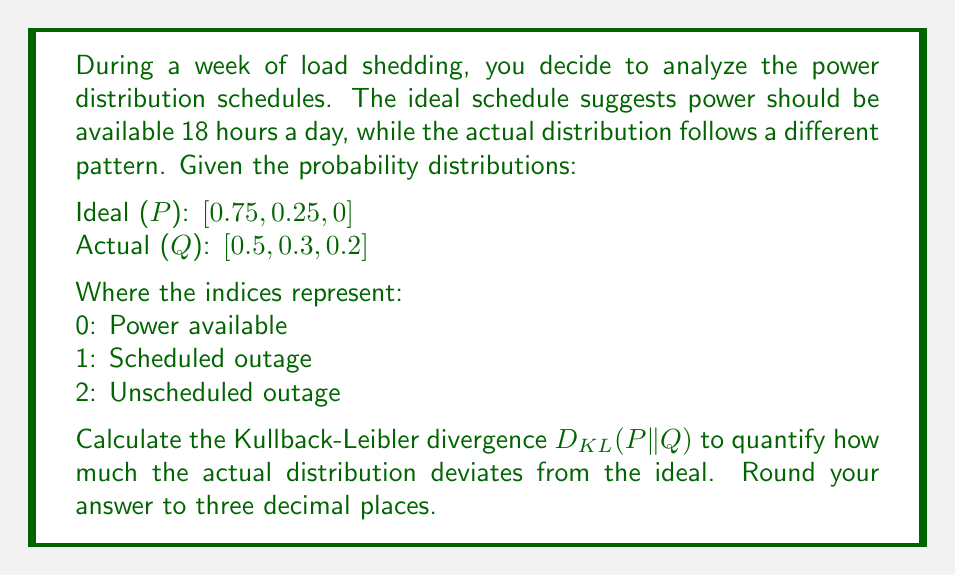Could you help me with this problem? To solve this problem, we'll use the Kullback-Leibler divergence formula:

$$D_{KL}(P||Q) = \sum_{i} P(i) \log \frac{P(i)}{Q(i)}$$

Let's calculate each term:

1) For i = 0 (Power available):
   $P(0) = 0.75$, $Q(0) = 0.5$
   $0.75 \log \frac{0.75}{0.5} = 0.75 \log 1.5 = 0.75 \cdot 0.4054651 = 0.3040988$

2) For i = 1 (Scheduled outage):
   $P(1) = 0.25$, $Q(1) = 0.3$
   $0.25 \log \frac{0.25}{0.3} = 0.25 \log 0.8333333 = 0.25 \cdot (-0.1823215) = -0.0455804$

3) For i = 2 (Unscheduled outage):
   $P(2) = 0$, $Q(2) = 0.2$
   $0 \log \frac{0}{0.2} = 0$ (by convention, $0 \log 0 = 0$)

Now, sum all these terms:

$$D_{KL}(P||Q) = 0.3040988 + (-0.0455804) + 0 = 0.2585184$$

Rounding to three decimal places: 0.259
Answer: 0.259 